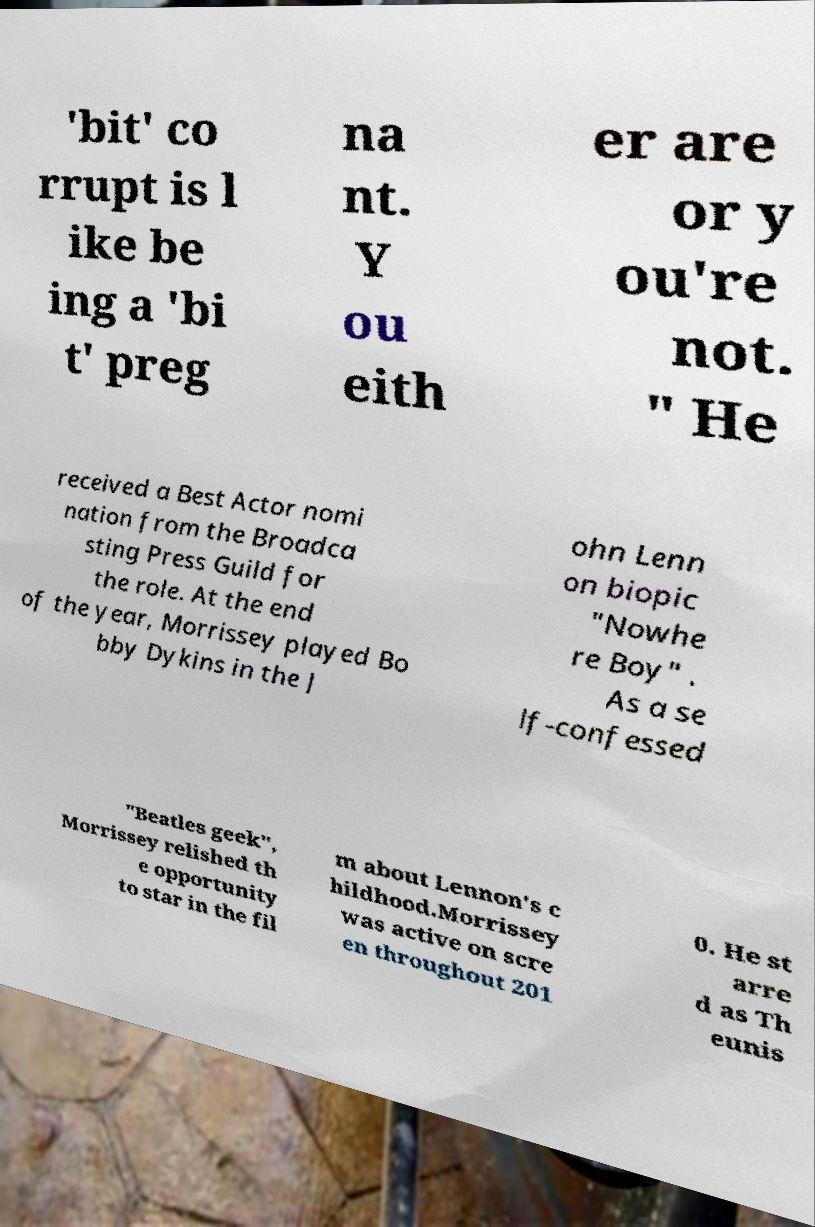Can you read and provide the text displayed in the image?This photo seems to have some interesting text. Can you extract and type it out for me? 'bit' co rrupt is l ike be ing a 'bi t' preg na nt. Y ou eith er are or y ou're not. " He received a Best Actor nomi nation from the Broadca sting Press Guild for the role. At the end of the year, Morrissey played Bo bby Dykins in the J ohn Lenn on biopic "Nowhe re Boy" . As a se lf-confessed "Beatles geek", Morrissey relished th e opportunity to star in the fil m about Lennon's c hildhood.Morrissey was active on scre en throughout 201 0. He st arre d as Th eunis 